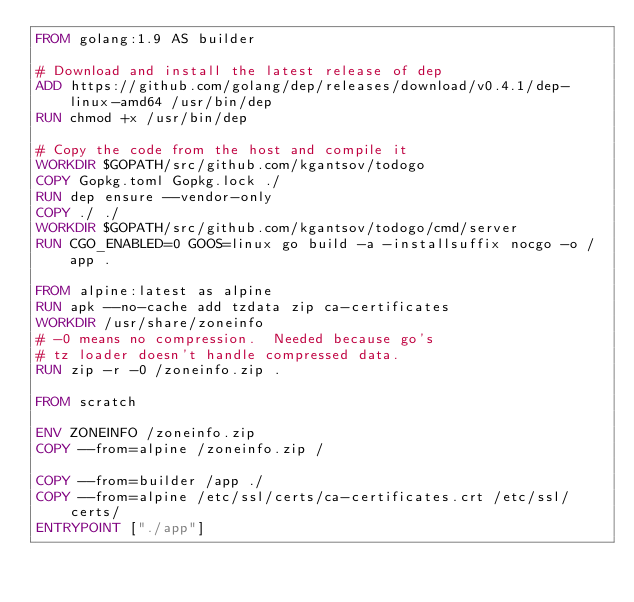<code> <loc_0><loc_0><loc_500><loc_500><_Dockerfile_>FROM golang:1.9 AS builder

# Download and install the latest release of dep
ADD https://github.com/golang/dep/releases/download/v0.4.1/dep-linux-amd64 /usr/bin/dep
RUN chmod +x /usr/bin/dep

# Copy the code from the host and compile it
WORKDIR $GOPATH/src/github.com/kgantsov/todogo
COPY Gopkg.toml Gopkg.lock ./
RUN dep ensure --vendor-only
COPY ./ ./
WORKDIR $GOPATH/src/github.com/kgantsov/todogo/cmd/server
RUN CGO_ENABLED=0 GOOS=linux go build -a -installsuffix nocgo -o /app .

FROM alpine:latest as alpine
RUN apk --no-cache add tzdata zip ca-certificates
WORKDIR /usr/share/zoneinfo
# -0 means no compression.  Needed because go's
# tz loader doesn't handle compressed data.
RUN zip -r -0 /zoneinfo.zip .

FROM scratch

ENV ZONEINFO /zoneinfo.zip
COPY --from=alpine /zoneinfo.zip /

COPY --from=builder /app ./
COPY --from=alpine /etc/ssl/certs/ca-certificates.crt /etc/ssl/certs/
ENTRYPOINT ["./app"]
</code> 